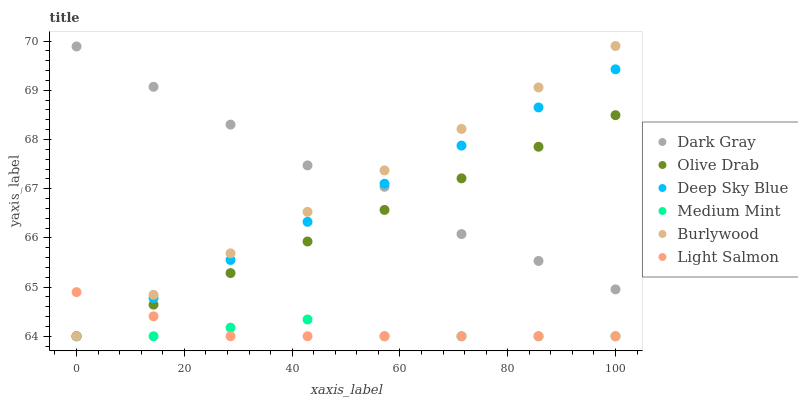Does Medium Mint have the minimum area under the curve?
Answer yes or no. Yes. Does Dark Gray have the maximum area under the curve?
Answer yes or no. Yes. Does Light Salmon have the minimum area under the curve?
Answer yes or no. No. Does Light Salmon have the maximum area under the curve?
Answer yes or no. No. Is Burlywood the smoothest?
Answer yes or no. Yes. Is Dark Gray the roughest?
Answer yes or no. Yes. Is Light Salmon the smoothest?
Answer yes or no. No. Is Light Salmon the roughest?
Answer yes or no. No. Does Medium Mint have the lowest value?
Answer yes or no. Yes. Does Dark Gray have the lowest value?
Answer yes or no. No. Does Burlywood have the highest value?
Answer yes or no. Yes. Does Light Salmon have the highest value?
Answer yes or no. No. Is Medium Mint less than Dark Gray?
Answer yes or no. Yes. Is Dark Gray greater than Light Salmon?
Answer yes or no. Yes. Does Deep Sky Blue intersect Medium Mint?
Answer yes or no. Yes. Is Deep Sky Blue less than Medium Mint?
Answer yes or no. No. Is Deep Sky Blue greater than Medium Mint?
Answer yes or no. No. Does Medium Mint intersect Dark Gray?
Answer yes or no. No. 